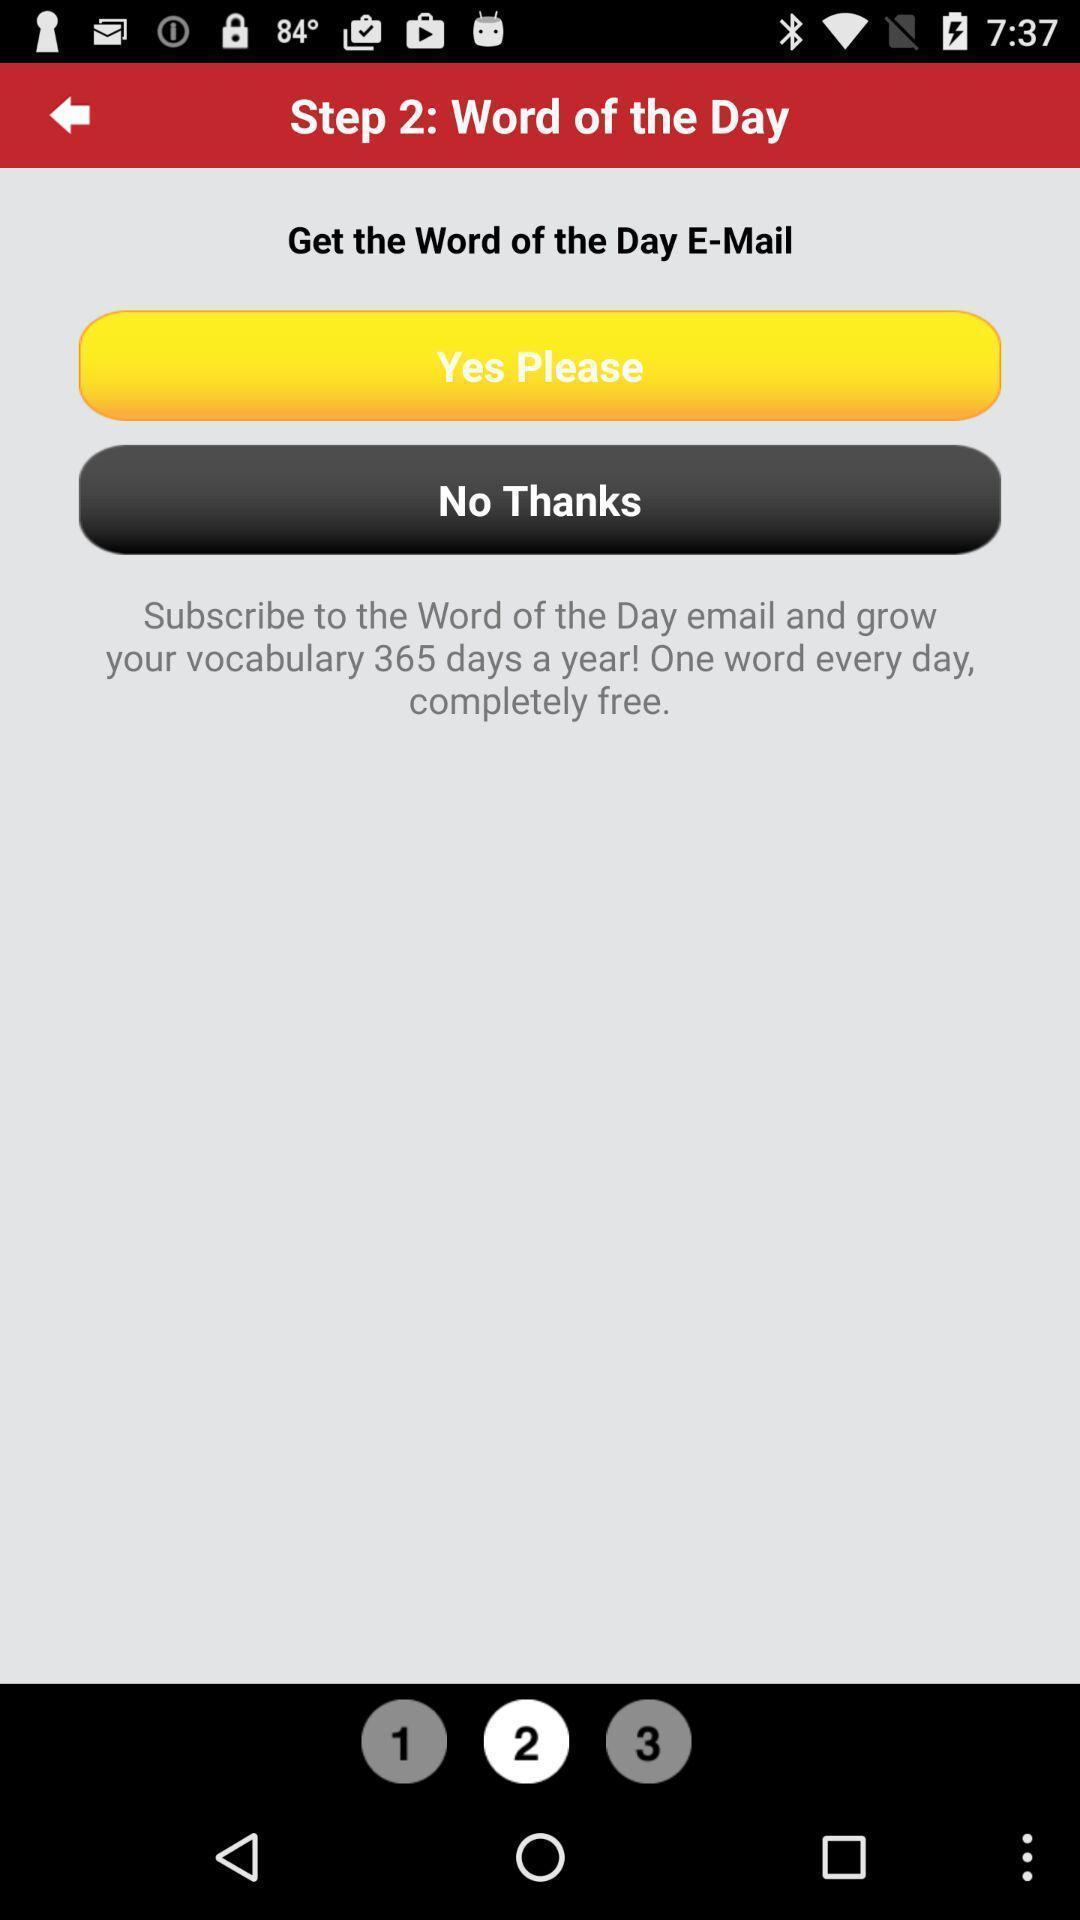Describe the key features of this screenshot. Screen displaying the options in a mail app. 